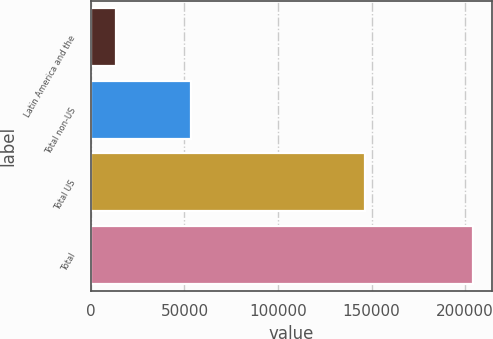<chart> <loc_0><loc_0><loc_500><loc_500><bar_chart><fcel>Latin America and the<fcel>Total non-US<fcel>Total US<fcel>Total<nl><fcel>13350<fcel>53617<fcel>146460<fcel>204175<nl></chart> 